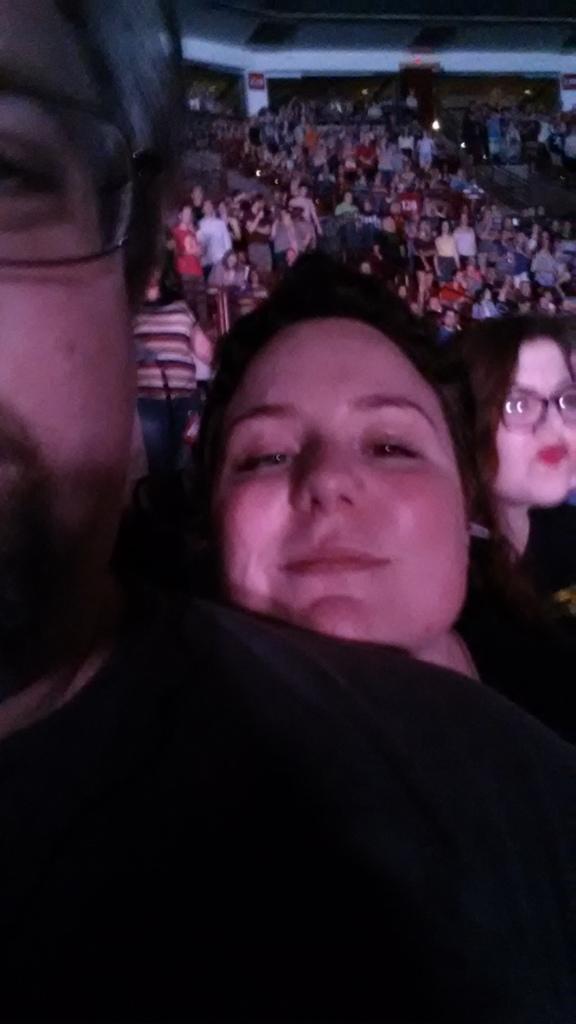How would you summarize this image in a sentence or two? In this image I can see a crowd, pillar and board. In the front of the image two people wore spectacles.   